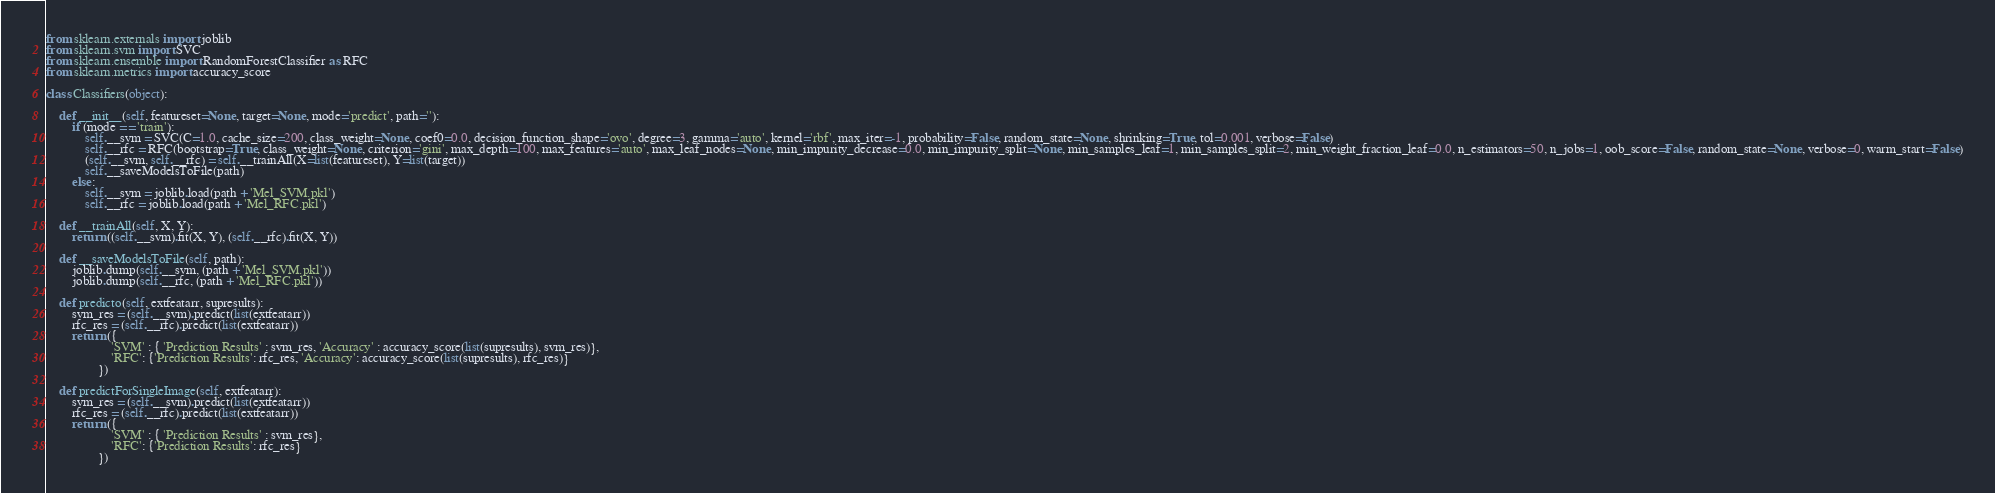Convert code to text. <code><loc_0><loc_0><loc_500><loc_500><_Python_>from sklearn.externals import joblib
from sklearn.svm import SVC
from sklearn.ensemble import RandomForestClassifier as RFC
from sklearn.metrics import accuracy_score

class Classifiers(object):

    def __init__(self, featureset=None, target=None, mode='predict', path=''):
        if (mode == 'train'):
            self.__svm = SVC(C=1.0, cache_size=200, class_weight=None, coef0=0.0, decision_function_shape='ovo', degree=3, gamma='auto', kernel='rbf', max_iter=-1, probability=False, random_state=None, shrinking=True, tol=0.001, verbose=False)
            self.__rfc = RFC(bootstrap=True, class_weight=None, criterion='gini', max_depth=100, max_features='auto', max_leaf_nodes=None, min_impurity_decrease=0.0, min_impurity_split=None, min_samples_leaf=1, min_samples_split=2, min_weight_fraction_leaf=0.0, n_estimators=50, n_jobs=1, oob_score=False, random_state=None, verbose=0, warm_start=False)
            (self.__svm, self.__rfc) = self.__trainAll(X=list(featureset), Y=list(target))
            self.__saveModelsToFile(path)
        else:
            self.__svm = joblib.load(path + 'Mel_SVM.pkl')
            self.__rfc = joblib.load(path + 'Mel_RFC.pkl')

    def __trainAll(self, X, Y):
        return ((self.__svm).fit(X, Y), (self.__rfc).fit(X, Y))

    def __saveModelsToFile(self, path):
        joblib.dump(self.__svm, (path + 'Mel_SVM.pkl'))
        joblib.dump(self.__rfc, (path + 'Mel_RFC.pkl'))

    def predicto(self, extfeatarr, supresults):
        svm_res = (self.__svm).predict(list(extfeatarr))
        rfc_res = (self.__rfc).predict(list(extfeatarr))
        return ({
                    'SVM' : { 'Prediction Results' : svm_res, 'Accuracy' : accuracy_score(list(supresults), svm_res)},
                    'RFC': {'Prediction Results': rfc_res, 'Accuracy': accuracy_score(list(supresults), rfc_res)}
                })

    def predictForSingleImage(self, extfeatarr):
        svm_res = (self.__svm).predict(list(extfeatarr))
        rfc_res = (self.__rfc).predict(list(extfeatarr))
        return ({
                    'SVM' : { 'Prediction Results' : svm_res},
                    'RFC': {'Prediction Results': rfc_res}
                })</code> 